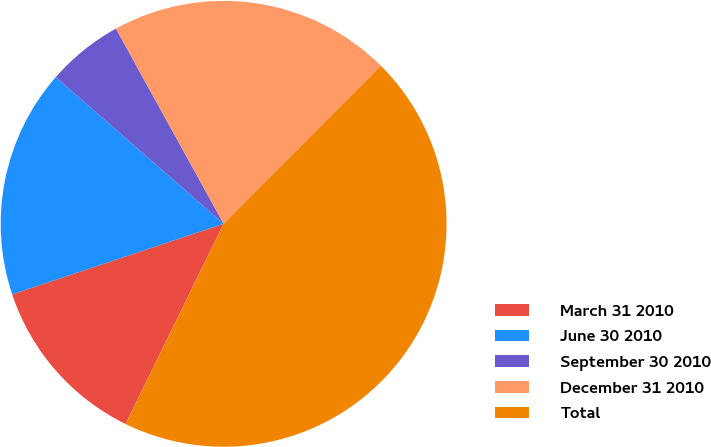Convert chart to OTSL. <chart><loc_0><loc_0><loc_500><loc_500><pie_chart><fcel>March 31 2010<fcel>June 30 2010<fcel>September 30 2010<fcel>December 31 2010<fcel>Total<nl><fcel>12.63%<fcel>16.56%<fcel>5.54%<fcel>20.48%<fcel>44.8%<nl></chart> 